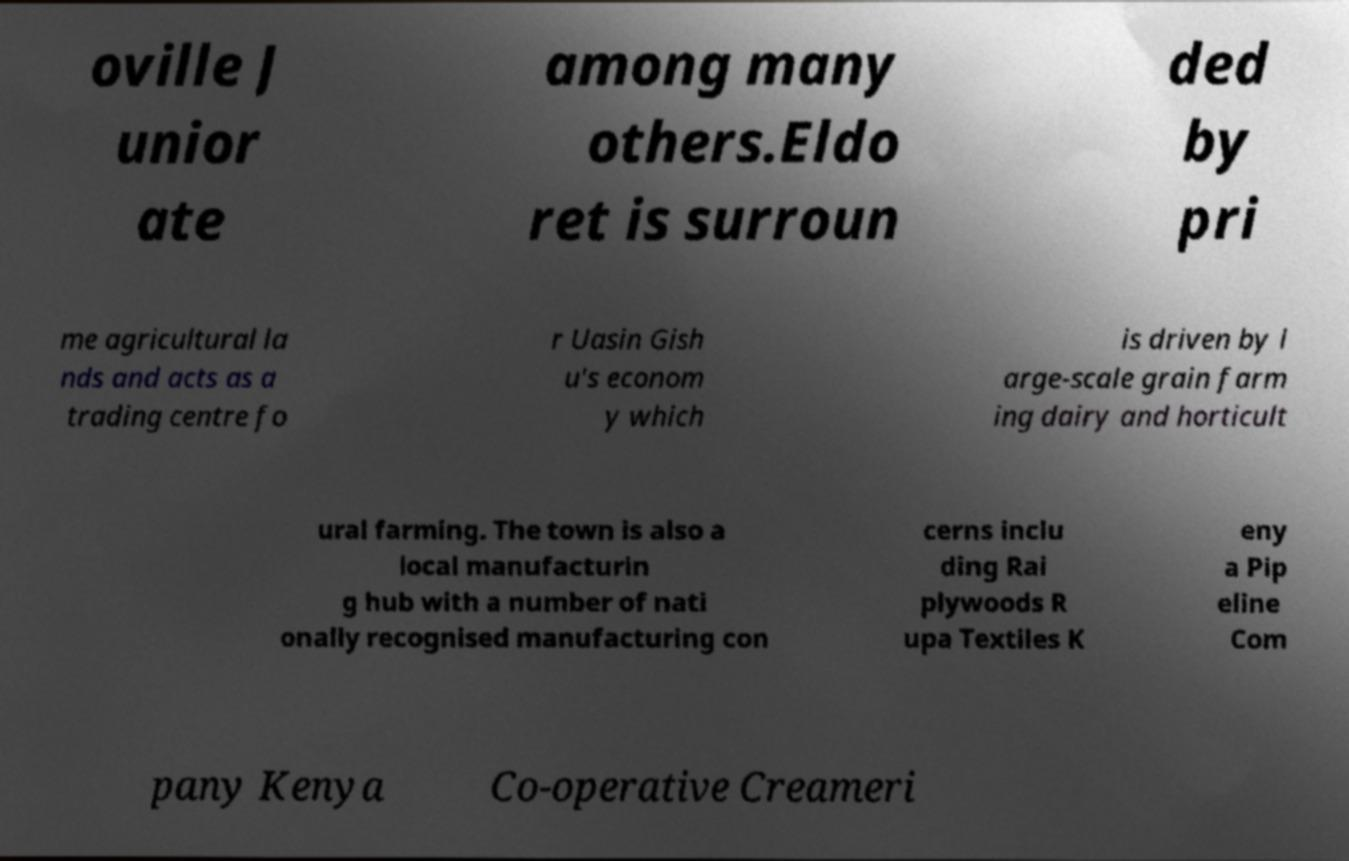Can you accurately transcribe the text from the provided image for me? oville J unior ate among many others.Eldo ret is surroun ded by pri me agricultural la nds and acts as a trading centre fo r Uasin Gish u's econom y which is driven by l arge-scale grain farm ing dairy and horticult ural farming. The town is also a local manufacturin g hub with a number of nati onally recognised manufacturing con cerns inclu ding Rai plywoods R upa Textiles K eny a Pip eline Com pany Kenya Co-operative Creameri 